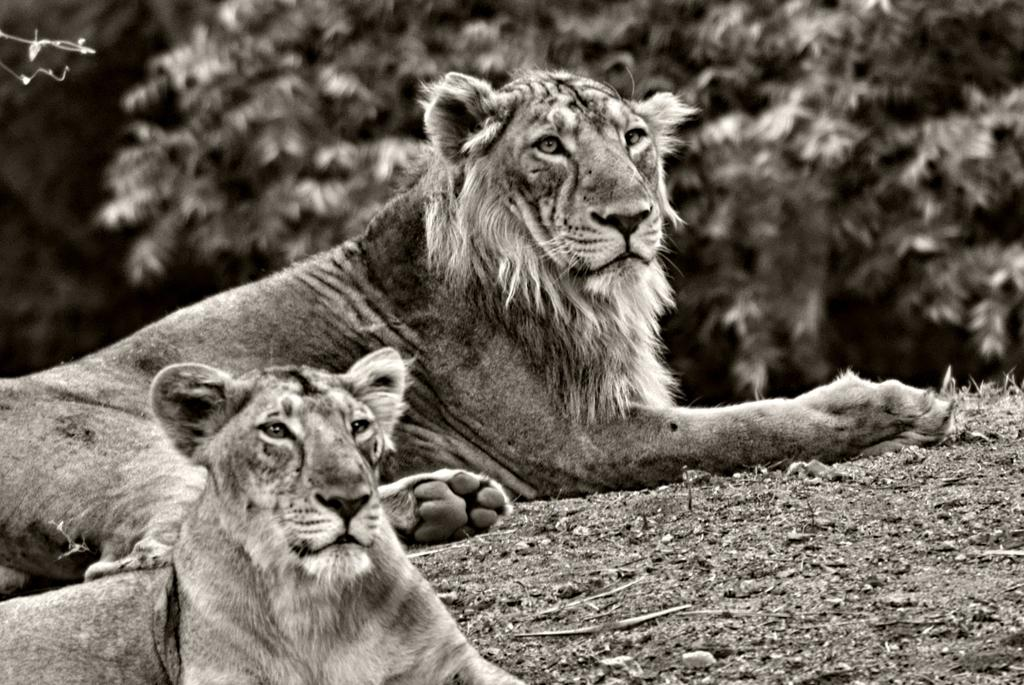What animals are present in the image? There are two lions in the image. Where are the lions located? The lions are on the ground. What can be seen in the background of the image? There are trees visible in the background of the image. What type of apple is hanging from the tree in the image? There is no apple present in the image; it features two lions on the ground with trees visible in the background. 